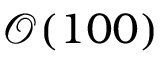<formula> <loc_0><loc_0><loc_500><loc_500>\mathcal { O } ( 1 0 0 )</formula> 